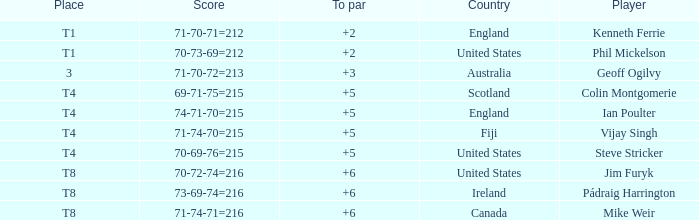What score to highest to par did Mike Weir achieve? 6.0. 